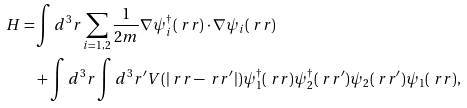<formula> <loc_0><loc_0><loc_500><loc_500>H = & \int d ^ { 3 } r \sum _ { i = 1 , 2 } \frac { 1 } { 2 m } \nabla \psi _ { i } ^ { \dagger } ( \ r r ) \cdot \nabla \psi _ { i } ( \ r r ) \\ & + \int d ^ { 3 } r \int d ^ { 3 } r ^ { \prime } V ( | \ r r - \ r r ^ { \prime } | ) \psi _ { 1 } ^ { \dagger } ( \ r r ) \psi _ { 2 } ^ { \dagger } ( \ r r ^ { \prime } ) \psi _ { 2 } ( \ r r ^ { \prime } ) \psi _ { 1 } ( \ r r ) ,</formula> 